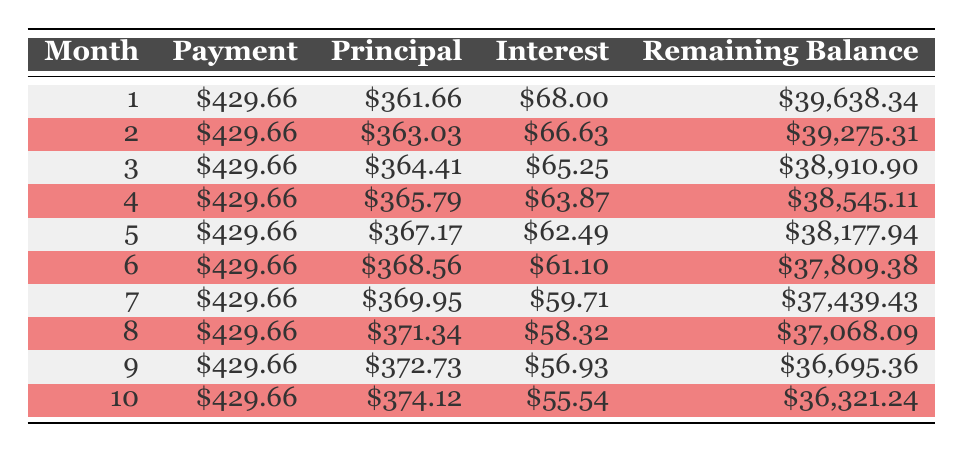What is the total amount paid over the loan term? The total amount paid is listed in the table as \$52,779.73.
Answer: 52779.73 What was the principal payment in the 5th month? If we look at the 5th month row in the table, the principal payment is shown as \$367.17.
Answer: 367.17 How much interest is paid in the 3rd month? The interest paid for the 3rd month is provided in the table as \$65.25.
Answer: 65.25 Does the monthly payment remain constant throughout the loan term? The table shows that each monthly payment is consistently \$429.66, indicating that it does remain constant.
Answer: Yes What is the remaining balance after the 7th payment? For the 7th month, the remaining balance after the payment can be found in the table, which shows it as \$37,439.43.
Answer: 37439.43 What is the total principal paid after the first 10 months? To get the total principal paid, sum the principal payments for each of the first ten months: \$361.66 + \$363.03 + \$364.41 + \$365.79 + \$367.17 + \$368.56 + \$369.95 + \$371.34 + \$372.73 + \$374.12 = \$3,268.76.
Answer: 3268.76 How does the interest paid change from month 1 to month 10? The interest paid decreases from \$68.00 in month 1 to \$55.54 in month 10, suggesting an overall decrease in interest as the loan is amortized.
Answer: Decreases What is the average principal payment over the first 10 months? The total principal paid over the first 10 months is \$3,268.76, and there are 10 months, so the average principal payment is \$3,268.76 / 10 = \$326.88.
Answer: 326.88 How does the remaining balance change from month 1 to month 10? The remaining balance decreases from \$39,638.34 in month 1 to \$36,321.24 in month 10, indicating that the borrower is steadily reducing the loan balance.
Answer: Decreases 